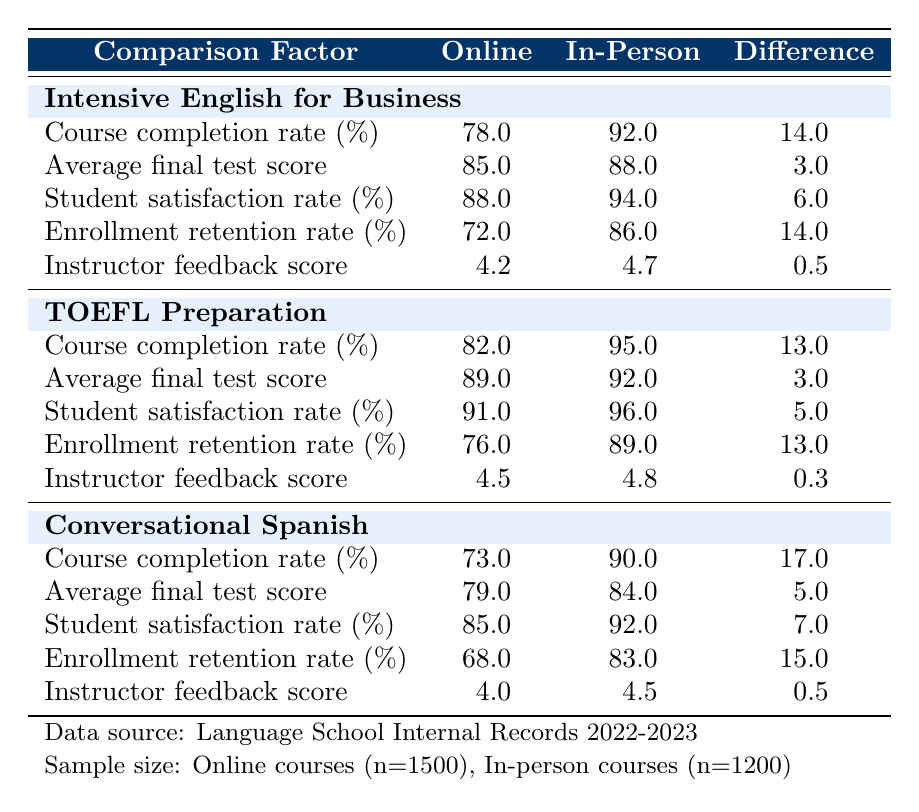What is the completion rate for the TOEFL Preparation course in online classes? The table indicates that the completion rate for the TOEFL Preparation course in online classes is 82.0%.
Answer: 82.0% Which course had the highest student satisfaction rate in in-person classes? Looking at the in-person courses, the TOEFL Preparation course has the highest student satisfaction rate at 96.0%.
Answer: TOEFL Preparation What is the difference in the instructor feedback score between the intensive English for Business course and the conversational Spanish course in in-person classes? According to the table, the instructor feedback score for the intensive English for Business course is 4.7 and for the conversational Spanish course is 4.5. The difference is 4.7 - 4.5 = 0.2.
Answer: 0.2 Is the average final test score for online TOEFL Preparation courses higher than that for in-person courses? The average final test score for the online TOEFL Preparation course is 89.0, while for in-person it is 92.0. Since 89.0 < 92.0, the statement is false.
Answer: No What is the overall average completion rate for online courses? To find the overall average completion rate for online courses: (78 + 82 + 73) / 3 = 77.67. Rounding gives approximately 77.7%.
Answer: 77.7% What is the enrollment retention rate for the conversational Spanish course in in-person classes? The table shows that the enrollment retention rate for the conversational Spanish course in in-person classes is 83.0%.
Answer: 83.0% How does the average final test score for in-person courses compare to that of online courses? The average final test scores for in-person courses are 88 (Intensive English), 92 (TOEFL), and 84 (Conversational Spanish), giving a total of 264/3 = 88. The online courses have 85 (Intensive English), 89 (TOEFL), and 79 (Conversational Spanish), totaling 253/3 = 84.33. So, in-person scores are higher.
Answer: In-person courses have higher scores Which online course has the lowest retention rate? The table states that the conversational Spanish course has a retention rate of 68.0%, which is lower than the others.
Answer: Conversational Spanish What is the difference in enrollment retention rates between online and in-person courses? To find the difference, we can average the retention rates for both: average online (72 + 76 + 68) / 3 = 72.67, and average in-person (86 + 89 + 83)/3 = 86. So, the difference is 86 - 72.67 = 13.33.
Answer: 13.33 